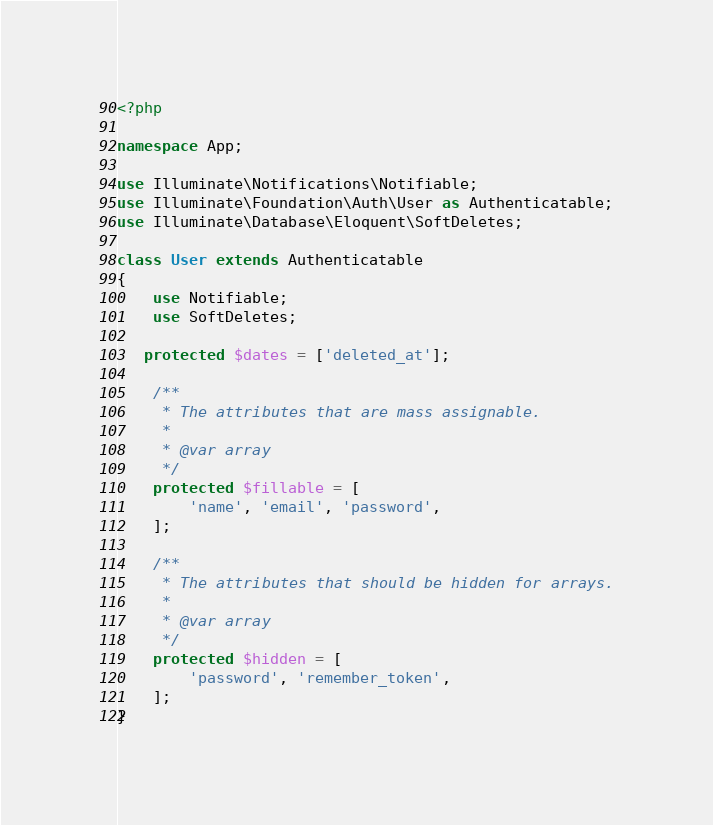<code> <loc_0><loc_0><loc_500><loc_500><_PHP_><?php

namespace App;

use Illuminate\Notifications\Notifiable;
use Illuminate\Foundation\Auth\User as Authenticatable;
use Illuminate\Database\Eloquent\SoftDeletes;

class User extends Authenticatable
{
    use Notifiable;
    use SoftDeletes;

   protected $dates = ['deleted_at'];

    /**
     * The attributes that are mass assignable.
     *
     * @var array
     */
    protected $fillable = [
        'name', 'email', 'password',
    ];

    /**
     * The attributes that should be hidden for arrays.
     *
     * @var array
     */
    protected $hidden = [
        'password', 'remember_token',
    ];
}
</code> 